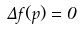<formula> <loc_0><loc_0><loc_500><loc_500>\Delta f ( p ) = 0</formula> 